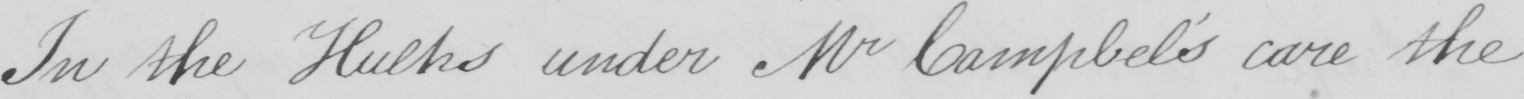Can you tell me what this handwritten text says? In the Hulks under Mr Campbel ' s care the 